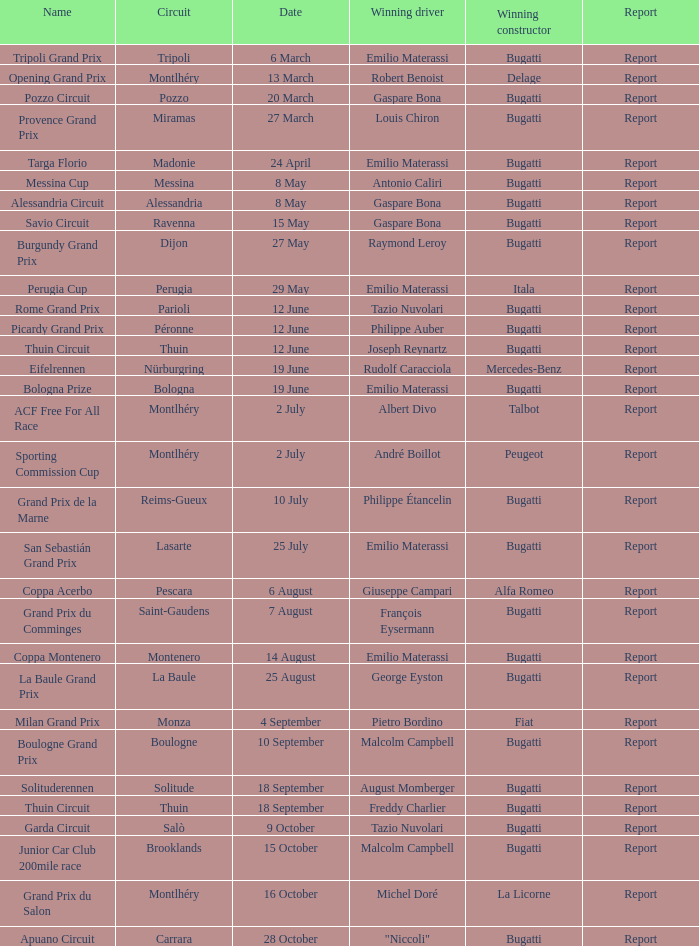Who was the winning constructor at the circuit of parioli? Bugatti. 